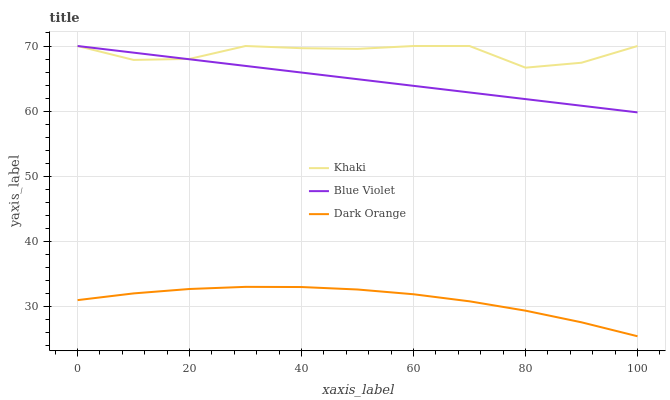Does Dark Orange have the minimum area under the curve?
Answer yes or no. Yes. Does Khaki have the maximum area under the curve?
Answer yes or no. Yes. Does Blue Violet have the minimum area under the curve?
Answer yes or no. No. Does Blue Violet have the maximum area under the curve?
Answer yes or no. No. Is Blue Violet the smoothest?
Answer yes or no. Yes. Is Khaki the roughest?
Answer yes or no. Yes. Is Khaki the smoothest?
Answer yes or no. No. Is Blue Violet the roughest?
Answer yes or no. No. Does Dark Orange have the lowest value?
Answer yes or no. Yes. Does Blue Violet have the lowest value?
Answer yes or no. No. Does Blue Violet have the highest value?
Answer yes or no. Yes. Is Dark Orange less than Khaki?
Answer yes or no. Yes. Is Blue Violet greater than Dark Orange?
Answer yes or no. Yes. Does Khaki intersect Blue Violet?
Answer yes or no. Yes. Is Khaki less than Blue Violet?
Answer yes or no. No. Is Khaki greater than Blue Violet?
Answer yes or no. No. Does Dark Orange intersect Khaki?
Answer yes or no. No. 